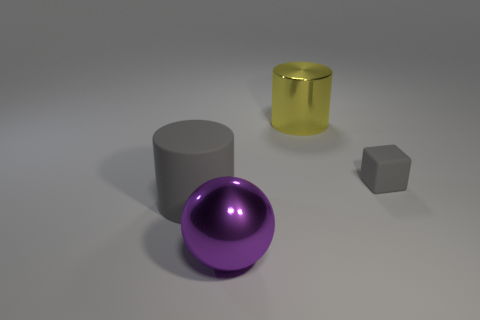Add 1 big metal cylinders. How many objects exist? 5 Subtract all blocks. How many objects are left? 3 Subtract all rubber things. Subtract all gray rubber cubes. How many objects are left? 1 Add 1 big rubber things. How many big rubber things are left? 2 Add 3 tiny green metallic objects. How many tiny green metallic objects exist? 3 Subtract 1 yellow cylinders. How many objects are left? 3 